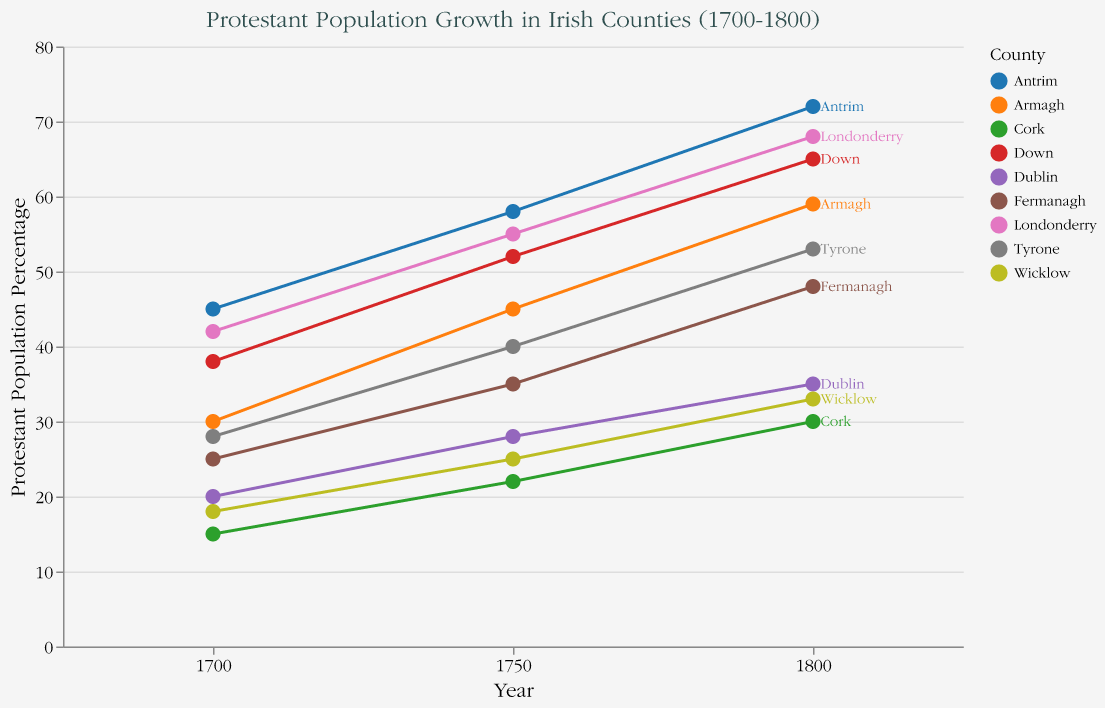What is the title of the figure? The title of the figure is displayed prominently at the top.
Answer: Protestant Population Growth in Irish Counties (1700-1800) Which county had the highest Protestant population percentage in 1700? By examining the data points for the year 1700, Antrim had the highest Protestant population percentage at 45%.
Answer: Antrim How did the Protestant population percentage in Antrim change from 1750 to 1800? Antrim's Protestant population percentage increased from 58% in 1750 to 72% in 1800. Subtracting the earlier value from the later value gives the change: 72% - 58% = 14%.
Answer: Increased by 14% Which county experienced the highest growth rate in the Protestant population percentage from 1700 to 1750? Comparing the growth rates for all counties from 1700 to 1750, Armagh experienced the highest growth rate at 0.50.
Answer: Armagh What is the average Protestant population percentage in Dublin over the three periods (1700, 1750, 1800)? To find the average, sum the percentages for 1700, 1750, and 1800, then divide by the number of years: (20 + 28 + 35) / 3 = 83 / 3 = 27.67.
Answer: 27.67 Which counties had a Protestant population percentage of 55% or more in 1800? By examining the data points for the year 1800, the counties with 55% or more Protestant population are Antrim (72%), Down (65%), Armagh (59%), and Londonderry (68%).
Answer: Antrim, Down, Armagh, Londonderry What was the Protestant population percentage in Cork in 1750? The data point for Cork in 1750 shows the Protestant population percentage as 22%.
Answer: 22% Which county had the smallest increase in Protestant population percentage from 1700 to 1800? By subtracting the 1700 values from the 1800 values for each county, Dublin has the smallest increase from 20% to 35%, which is an increase of 15%.
Answer: Dublin How much did the Protestant population percentage in Wicklow increase from 1700 to 1750, and then from 1750 to 1800? The increase from 1700 to 1750 is 25% - 18% = 7%. The increase from 1750 to 1800 is 33% - 25% = 8%.
Answer: 7%, 8% Which county had a consistent growth rate in the Protestant population between each period? By comparing the growth rates between 1700-1750 and 1750-1800, no county shows the exact same growth rate across both periods. However, Antrim had relatively similar rates of 0.29 and 0.24.
Answer: None with exactly the same rate, but Antrim is close 